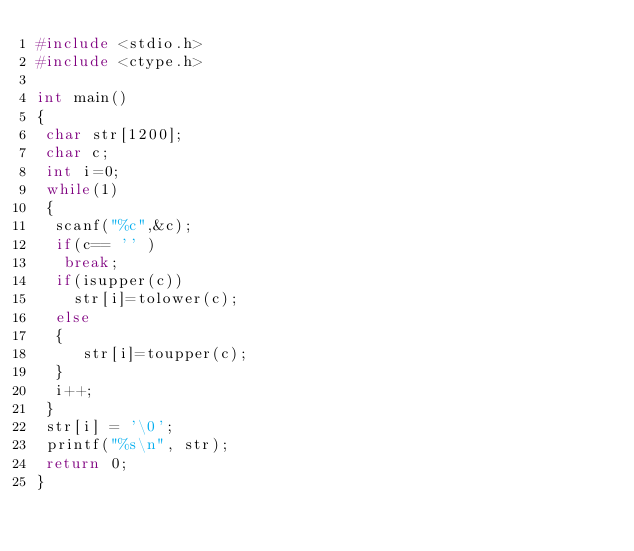Convert code to text. <code><loc_0><loc_0><loc_500><loc_500><_C_>#include <stdio.h>
#include <ctype.h>

int main()
{
 char str[1200];
 char c;
 int i=0;
 while(1)
 {
  scanf("%c",&c);
  if(c== '' )
   break;
  if(isupper(c))
    str[i]=tolower(c);
  else
  {
     str[i]=toupper(c);
  }
  i++;
 }
 str[i] = '\0';
 printf("%s\n", str);
 return 0;
}</code> 